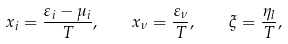Convert formula to latex. <formula><loc_0><loc_0><loc_500><loc_500>x _ { i } = \frac { \varepsilon _ { i } - \mu _ { i } } { T } , \quad x _ { \nu } = \frac { \varepsilon _ { \nu } } { T } , \quad \xi = \frac { \eta _ { l } } { T } ,</formula> 